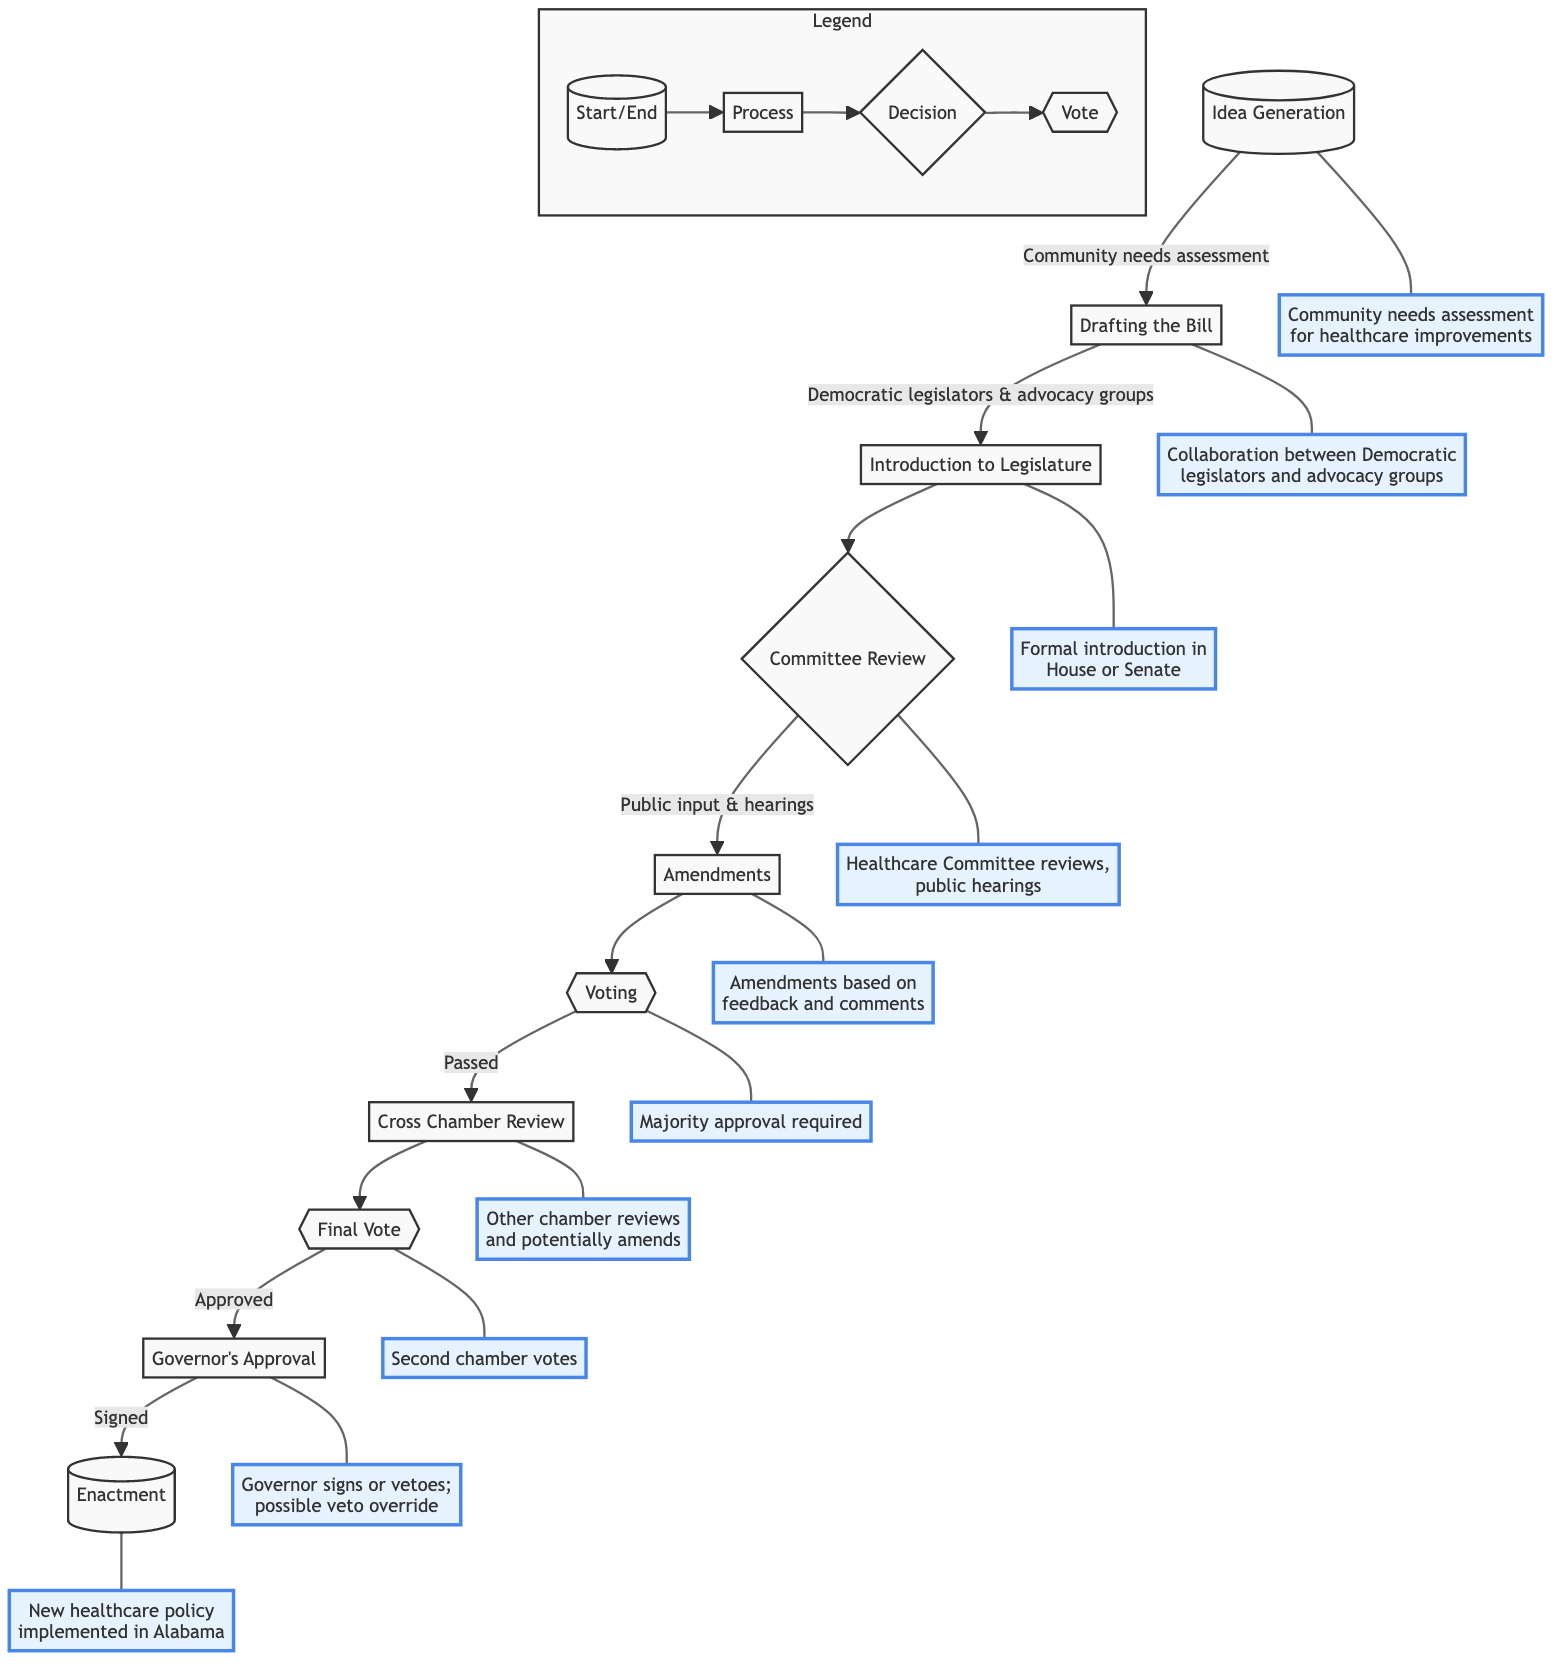What is the first stage in the legislative process? The flow chart starts with the "Idea Generation" stage, which is where community needs assessment for healthcare improvements takes place.
Answer: Idea Generation How many stages are there in total? By counting the stages listed in the diagram, there are ten distinct stages from "Idea Generation" to "Enactment."
Answer: 10 Which stage involves collaboration between legislators and advocacy groups? The "Drafting the Bill" stage specifically mentions that collaboration occurs between Democratic legislators and healthcare advocacy groups.
Answer: Drafting the Bill What happens after the "Committee Review"? Following the "Committee Review," the next stage is "Amendments," where the bill is amended based on committee feedback and public comments.
Answer: Amendments What type of review occurs in the "Cross Chamber Review" stage? The "Cross Chamber Review" stage signifies that the bill is sent to the other chamber for review and potential amendments if it has passed the originating chamber.
Answer: Review and potential amendments What is required for the "Voting" stage to proceed? The "Voting" stage requires majority approval in the originating chamber for the bill to move forward.
Answer: Majority approval What is the decision made during the "Governor's Approval" stage? In the "Governor's Approval" stage, the Governor decides whether to sign the bill into law or veto it.
Answer: Sign or veto What is the final outcome after the "Governor's Approval" if the bill is signed? If the bill is signed by the Governor, it becomes law, and the last stage is "Enactment," where the new healthcare policy is implemented in Alabama.
Answer: Enactment Which stage may allow for public input? The "Committee Review" stage is where public input is gathered, including testimonies from local health professionals during hearings.
Answer: Committee Review 